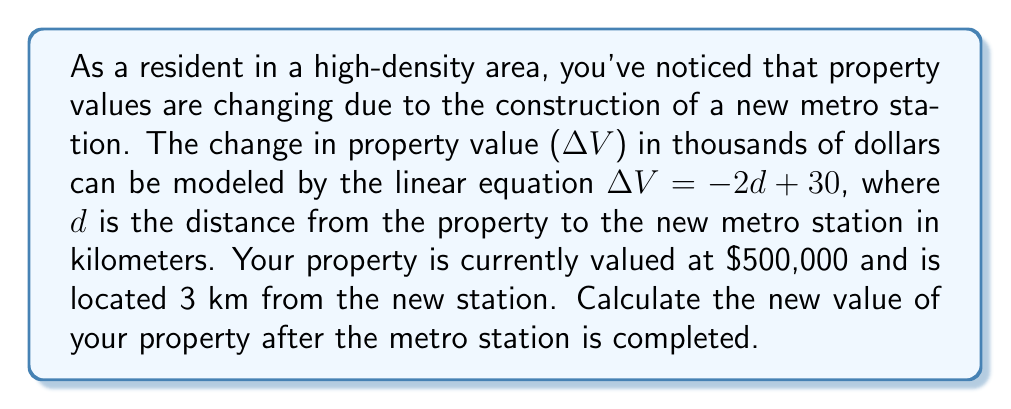Can you answer this question? To solve this problem, we'll follow these steps:

1) First, let's calculate the change in property value ($$\Delta V$$) using the given equation:
   $$\Delta V = -2d + 30$$
   Where $$d = 3$$ km (the distance of your property from the station)

   $$\Delta V = -2(3) + 30$$
   $$\Delta V = -6 + 30 = 24$$

   This means the property value will increase by $24,000.

2) Now, we need to add this increase to the current property value:
   Current value = $500,000
   Increase = $24,000

   New value = Current value + Increase
              = $500,000 + $24,000
              = $524,000

Therefore, the new value of your property after the metro station is completed will be $524,000.
Answer: $524,000 